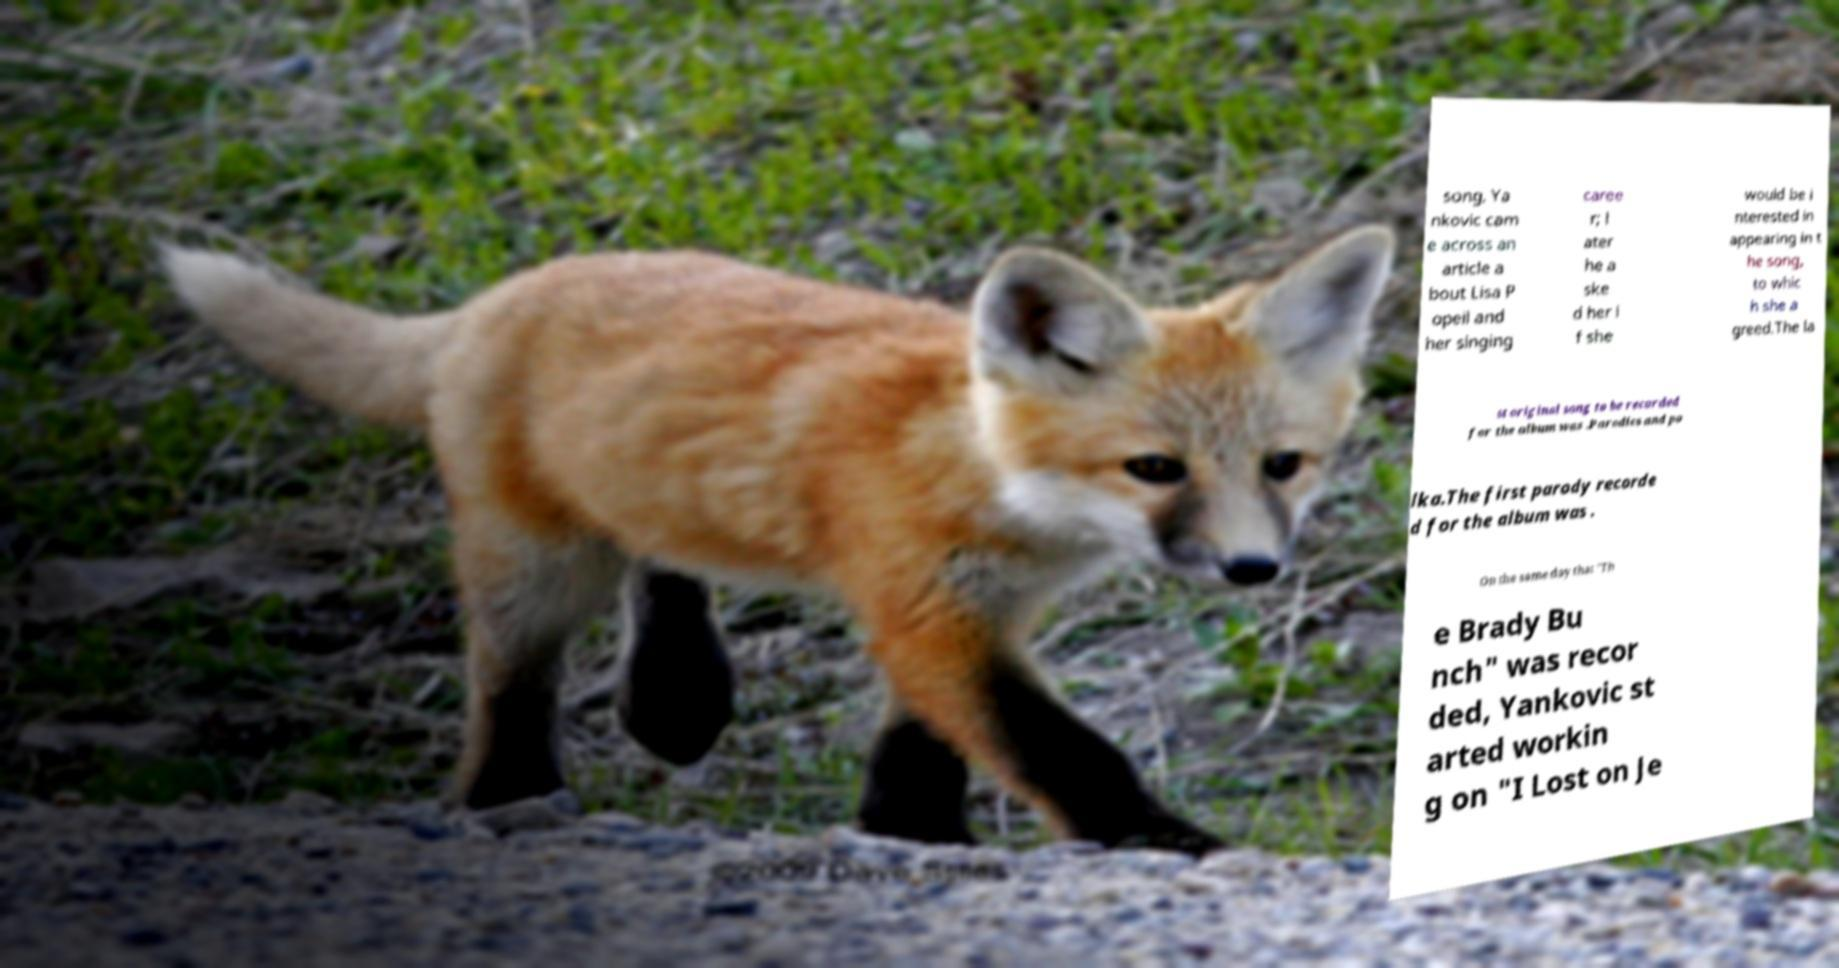What messages or text are displayed in this image? I need them in a readable, typed format. song, Ya nkovic cam e across an article a bout Lisa P opeil and her singing caree r; l ater he a ske d her i f she would be i nterested in appearing in t he song, to whic h she a greed.The la st original song to be recorded for the album was .Parodies and po lka.The first parody recorde d for the album was . On the same day that "Th e Brady Bu nch" was recor ded, Yankovic st arted workin g on "I Lost on Je 